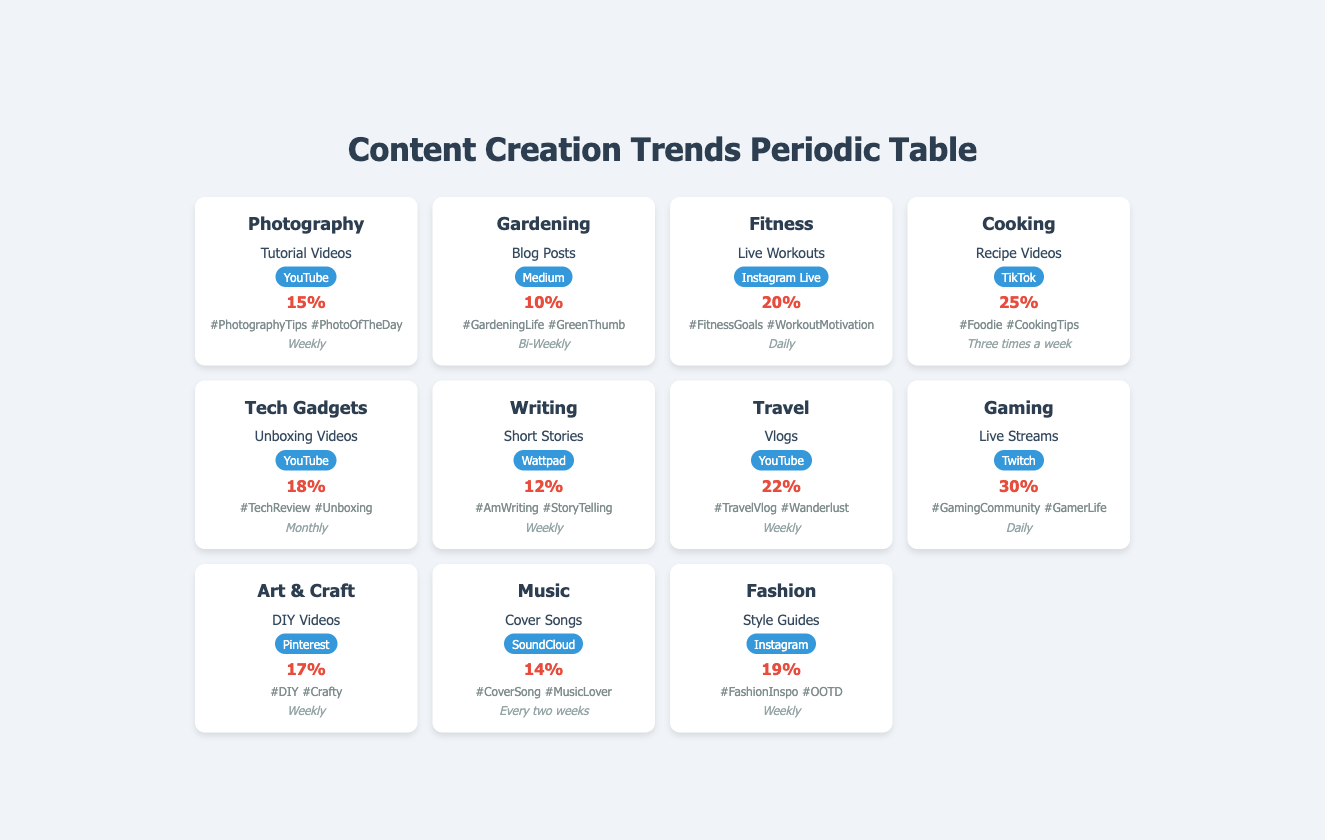What is the engagement rate for the Gaming hobby group? The table shows a specific entry for the Gaming hobby group, which lists the engagement rate as 30%. This is retrieved directly from the row corresponding to Gaming.
Answer: 30% Which content type has the highest engagement rate? To identify the content type with the highest engagement rate, compare the engagement rates listed for all hobby groups. Cooking has the highest engagement rate at 25%, so it is the content type associated with the Cooking hobby group.
Answer: Recipe Videos How frequently do Photography enthusiasts create content? The table indicates that the content frequency for Photography is marked as "Weekly." This value is specific to the Photography hobby group entry.
Answer: Weekly What is the average engagement rate for all hobby groups listed? First, list all the engagement rates from the table: 15%, 10%, 20%, 25%, 18%, 12%, 22%, 30%, 17%, 14%, and 19%. Summing these gives a total of 15 + 10 + 20 + 25 + 18 + 12 + 22 + 30 + 17 + 14 + 19 =  182. There are 11 hobby groups, so divide the total by 11 to get the average: 182 / 11 ≈ 16.55%.
Answer: Approximately 16.55% Do users in the Fitness hobby group create content more frequently than those in the Gardening group? The Fitness hobby group has a content frequency of "Daily," while the Gardening hobby group has a frequency of "Bi-Weekly." Therefore, Fitness users create content more frequently than those in Gardening.
Answer: Yes Which platforms are used for sharing Cooking and Tech Gadgets content types? From the table, Cooking content is shared on TikTok and Tech Gadgets content is on YouTube. Therefore, both platforms are used for these respective hobby groups.
Answer: TikTok and YouTube What percentage of content creators in the Music hobby group share content every two weeks? The Music hobby group has a specified content frequency of "Every two weeks." This means that 100% of creators in Music group share content every two weeks because it is the only frequency given for that group.
Answer: 100% Is the engagement rate for Art & Craft higher than that for Writing? The engagement rate for Art & Craft is 17% and for Writing it is 12%. Since 17% is higher than 12%, the engagement rate for Art & Craft is indeed higher.
Answer: Yes What is the content frequency for the Travel hobby group, and how does it compare to that of the Gaming hobby group? The Travel hobby group creates content with a frequency of "Weekly," while the Gaming group has a frequency of "Daily." This means Travel creates content less frequently than Gaming.
Answer: Weekly; lower than Gaming's Daily What are the popular hashtags used by Fitness and Cooking hobby groups? The Fitness hobby group uses the hashtags "#FitnessGoals" and "#WorkoutMotivation," while the Cooking hobby group uses "#Foodie" and "#CookingTips." Thus, these are the corresponding hashtags for each group.
Answer: Fitness: #FitnessGoals, #WorkoutMotivation; Cooking: #Foodie, #CookingTips 